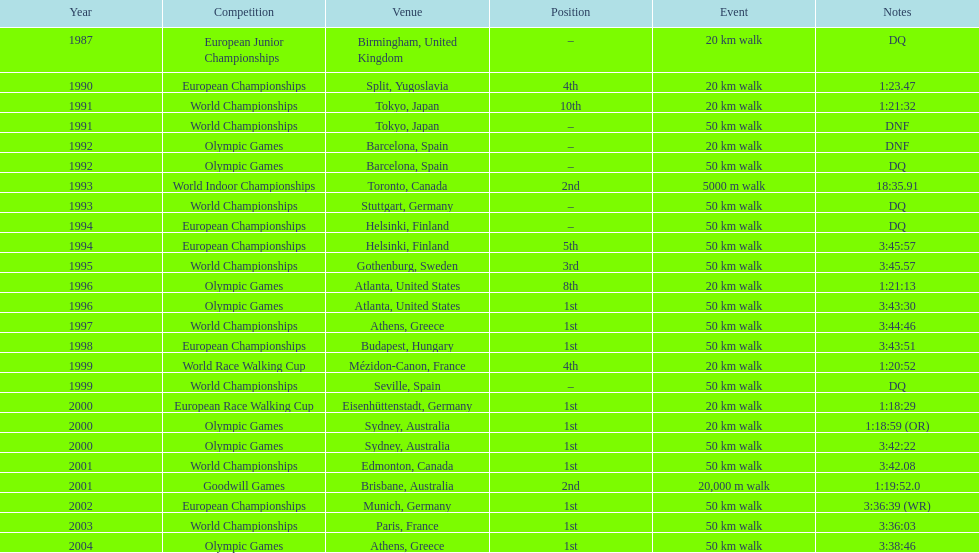How did korzeniowski's 20 km walk performance differ between the 1996 and 2000 olympic games? 2:14. 